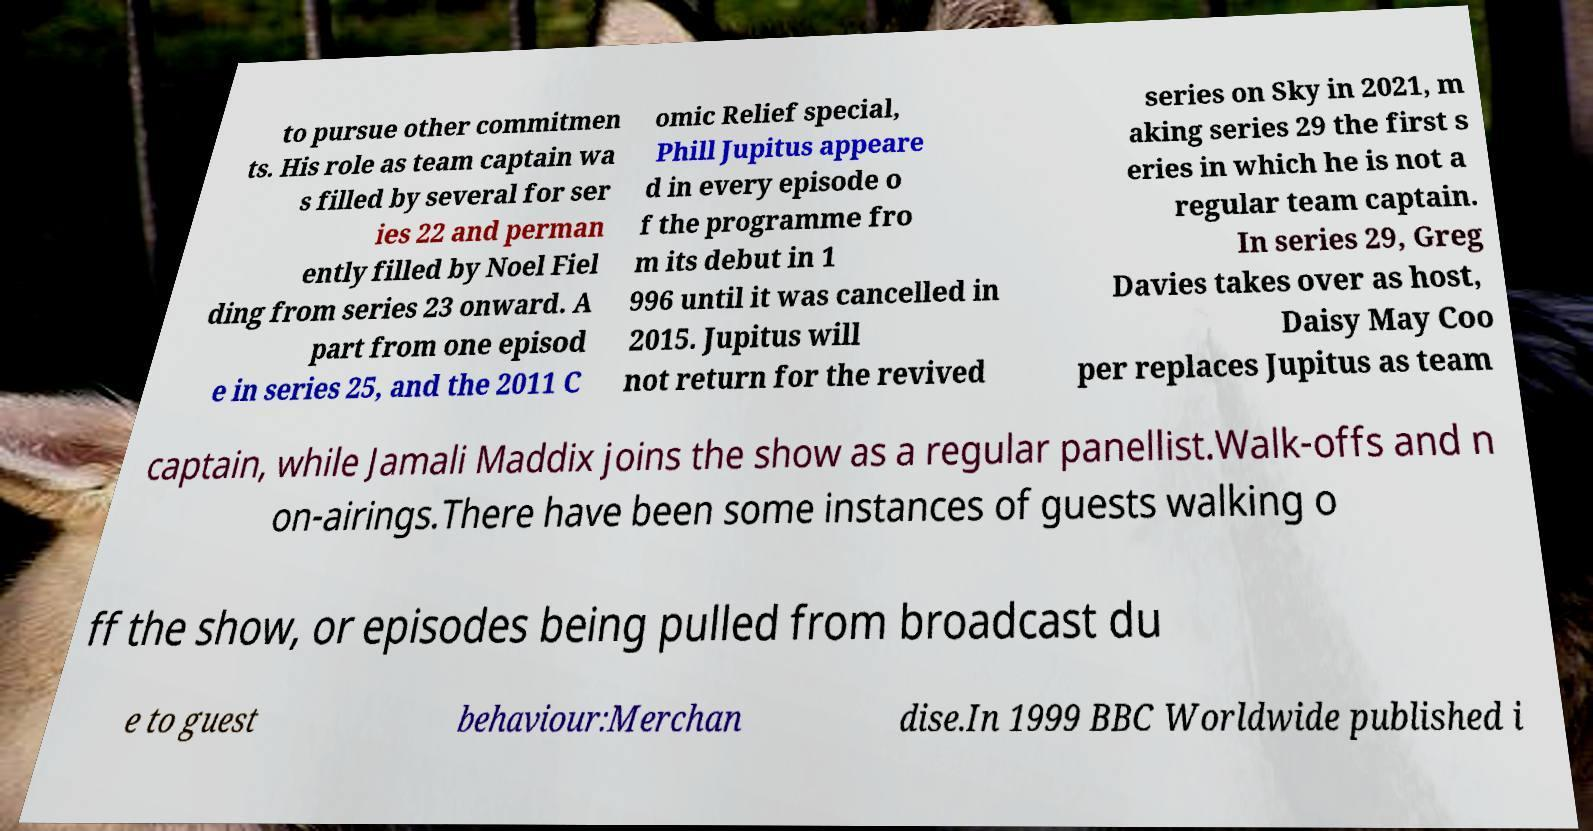There's text embedded in this image that I need extracted. Can you transcribe it verbatim? to pursue other commitmen ts. His role as team captain wa s filled by several for ser ies 22 and perman ently filled by Noel Fiel ding from series 23 onward. A part from one episod e in series 25, and the 2011 C omic Relief special, Phill Jupitus appeare d in every episode o f the programme fro m its debut in 1 996 until it was cancelled in 2015. Jupitus will not return for the revived series on Sky in 2021, m aking series 29 the first s eries in which he is not a regular team captain. In series 29, Greg Davies takes over as host, Daisy May Coo per replaces Jupitus as team captain, while Jamali Maddix joins the show as a regular panellist.Walk-offs and n on-airings.There have been some instances of guests walking o ff the show, or episodes being pulled from broadcast du e to guest behaviour:Merchan dise.In 1999 BBC Worldwide published i 